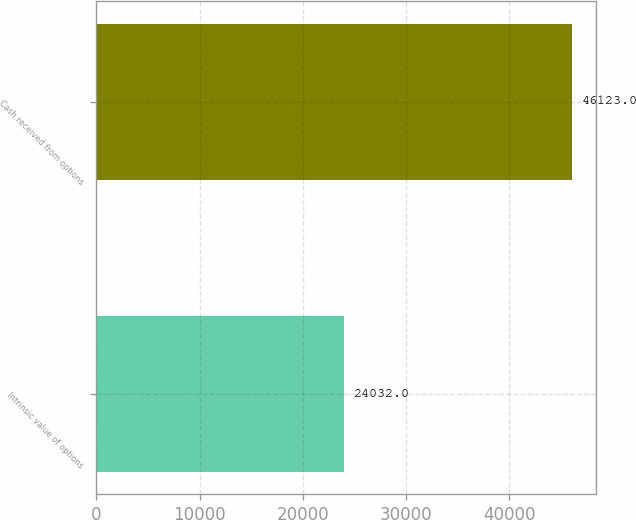Convert chart to OTSL. <chart><loc_0><loc_0><loc_500><loc_500><bar_chart><fcel>Intrinsic value of options<fcel>Cash received from options<nl><fcel>24032<fcel>46123<nl></chart> 